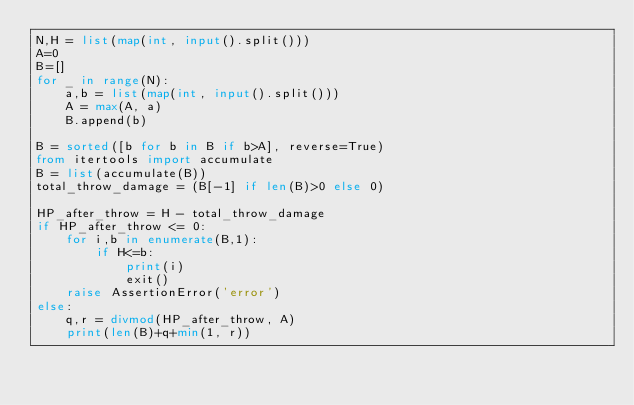<code> <loc_0><loc_0><loc_500><loc_500><_Python_>N,H = list(map(int, input().split()))
A=0
B=[]
for _ in range(N):
    a,b = list(map(int, input().split()))
    A = max(A, a)
    B.append(b)

B = sorted([b for b in B if b>A], reverse=True)
from itertools import accumulate
B = list(accumulate(B))
total_throw_damage = (B[-1] if len(B)>0 else 0)

HP_after_throw = H - total_throw_damage
if HP_after_throw <= 0:
    for i,b in enumerate(B,1):
        if H<=b:
            print(i)
            exit()
    raise AssertionError('error')
else:
    q,r = divmod(HP_after_throw, A)
    print(len(B)+q+min(1, r))
</code> 